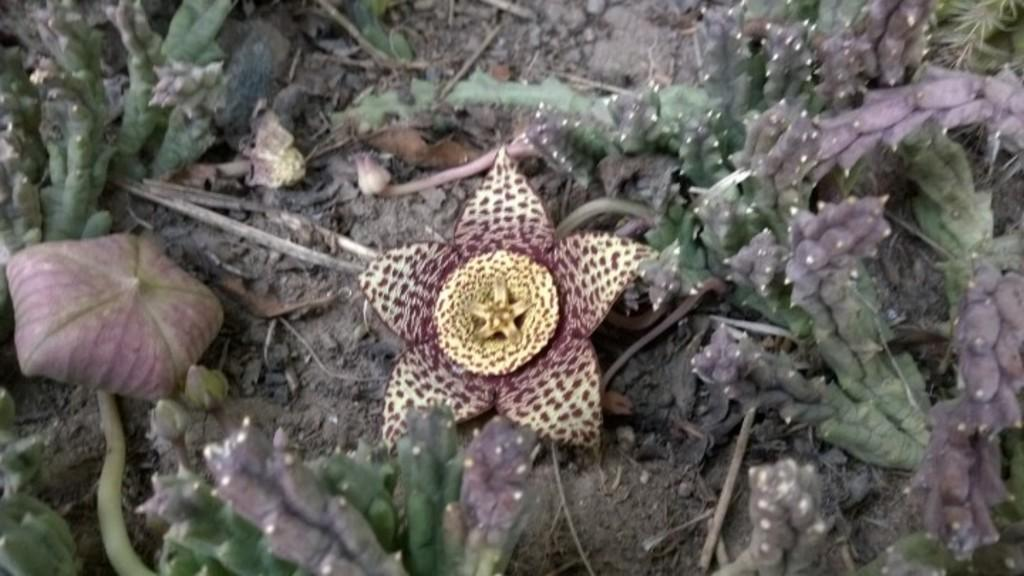What is the main subject in the center of the image? There is a flower in the center of the image. What else can be seen in the image that is related to the flower? There are objects that appear to be leaves and stems of plants in the image. Are there any other objects in the image besides the flower and its related parts? Yes, there are other unspecified objects in the image. What type of sweater is the bear wearing in the image? There are no bears or sweaters present in the image; it features a flower and related plant parts. 